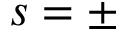Convert formula to latex. <formula><loc_0><loc_0><loc_500><loc_500>s = \pm</formula> 